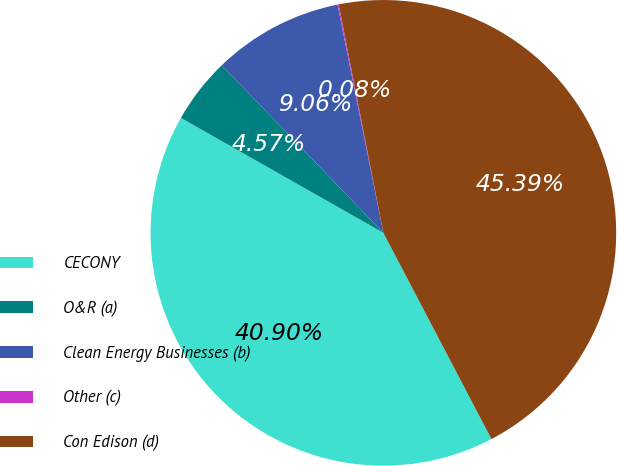Convert chart to OTSL. <chart><loc_0><loc_0><loc_500><loc_500><pie_chart><fcel>CECONY<fcel>O&R (a)<fcel>Clean Energy Businesses (b)<fcel>Other (c)<fcel>Con Edison (d)<nl><fcel>40.9%<fcel>4.57%<fcel>9.06%<fcel>0.08%<fcel>45.39%<nl></chart> 